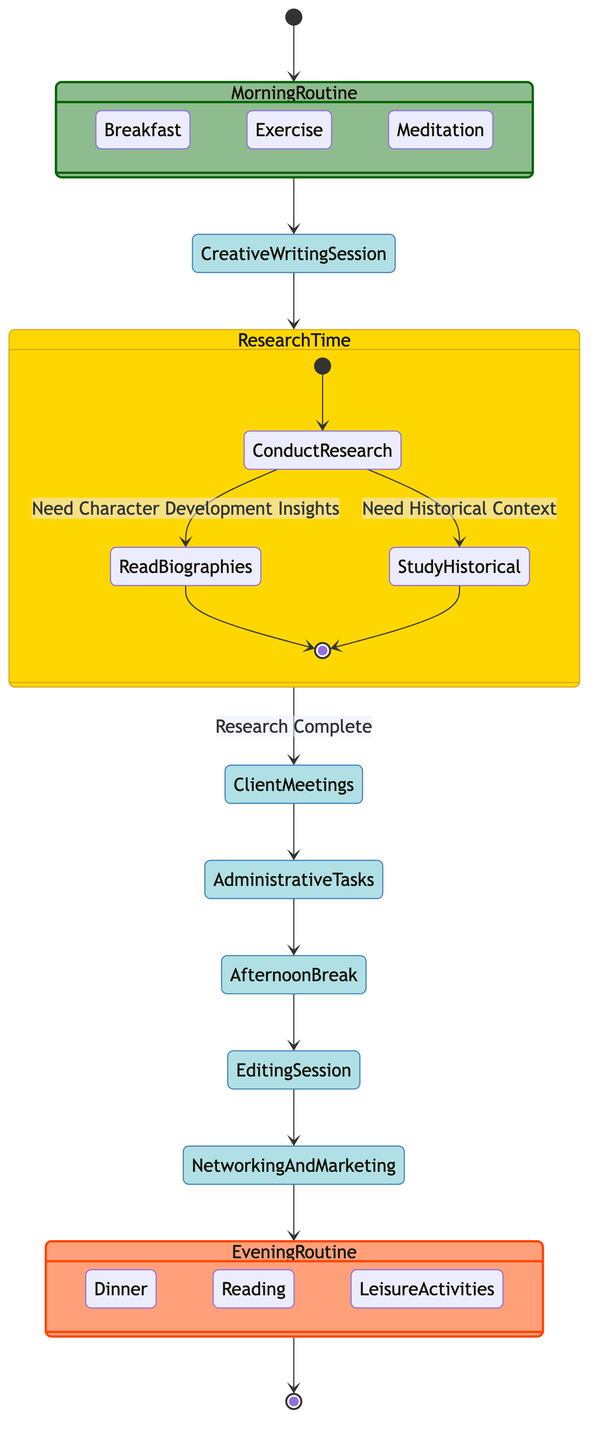What initiates the diagram? The diagram starts with the initial state, which is represented by the "Start Day" activity. This indicates the beginning of the writer's daily routine.
Answer: Start Day What are the three activities included in the Morning Routine? TheMorning Routine contains three activities: "Breakfast," "Exercise," and "Meditation," which are defined in the diagram.
Answer: Breakfast, Exercise, Meditation How many decision points are present in the diagram? There is one decision point in the diagram, which occurs during the "Research Time" activity, where the writer decides on the type of research to conduct.
Answer: One What happens after completing the Editing Session? After the "Editing Session," the next activity listed is "Networking and Marketing," showing that these activities are sequential.
Answer: Networking and Marketing What condition allows the writer to move from Research Time to Client Meetings? The transition from "Research Time" to "Client Meetings" occurs under the condition "Research Complete," indicating that research must be finished first.
Answer: Research Complete What is the final activity listed in the diagram? The final activity in the diagram is "Evening Routine," which symbolizes the end of the writer's daily schedule and consists of winding down activities.
Answer: Evening Routine How many activities are there in total (excluding initial and final states)? There are seven activities in total, excluding the initial "Start Day" and the final "Evening Routine," as counted from the diagram's activities section.
Answer: Seven Which activity directly follows the Afternoon Break? The activity that follows "Afternoon Break" in the sequence is "Editing Session," indicating what the writer does next after their break.
Answer: Editing Session What type of activities are present in the Evening Routine? The Evening Routine consists of activities such as "Dinner," "Reading," and "Leisure Activities," showcasing the writer's winding down process.
Answer: Dinner, Reading, Leisure Activities 